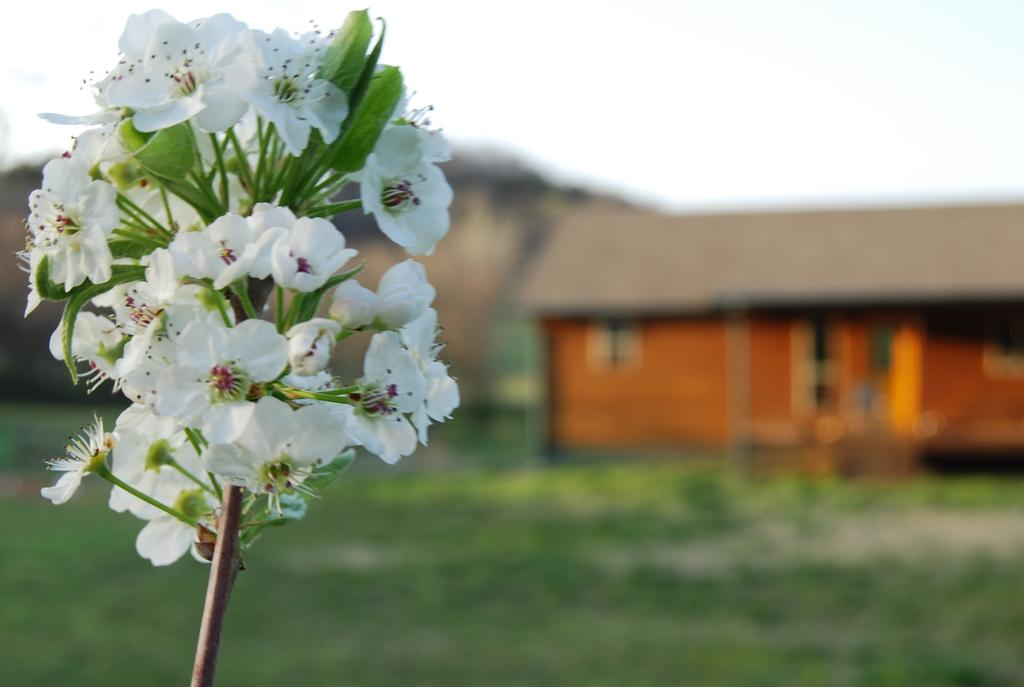What type of plants can be seen in the image? There are flowers in the image. What structure is located on the right side of the image? There is a hut on the right side of the image. Can you describe the background of the image? The background of the image is blurred. What type of writing can be seen on the flowers in the image? There is no writing present on the flowers in the image. 